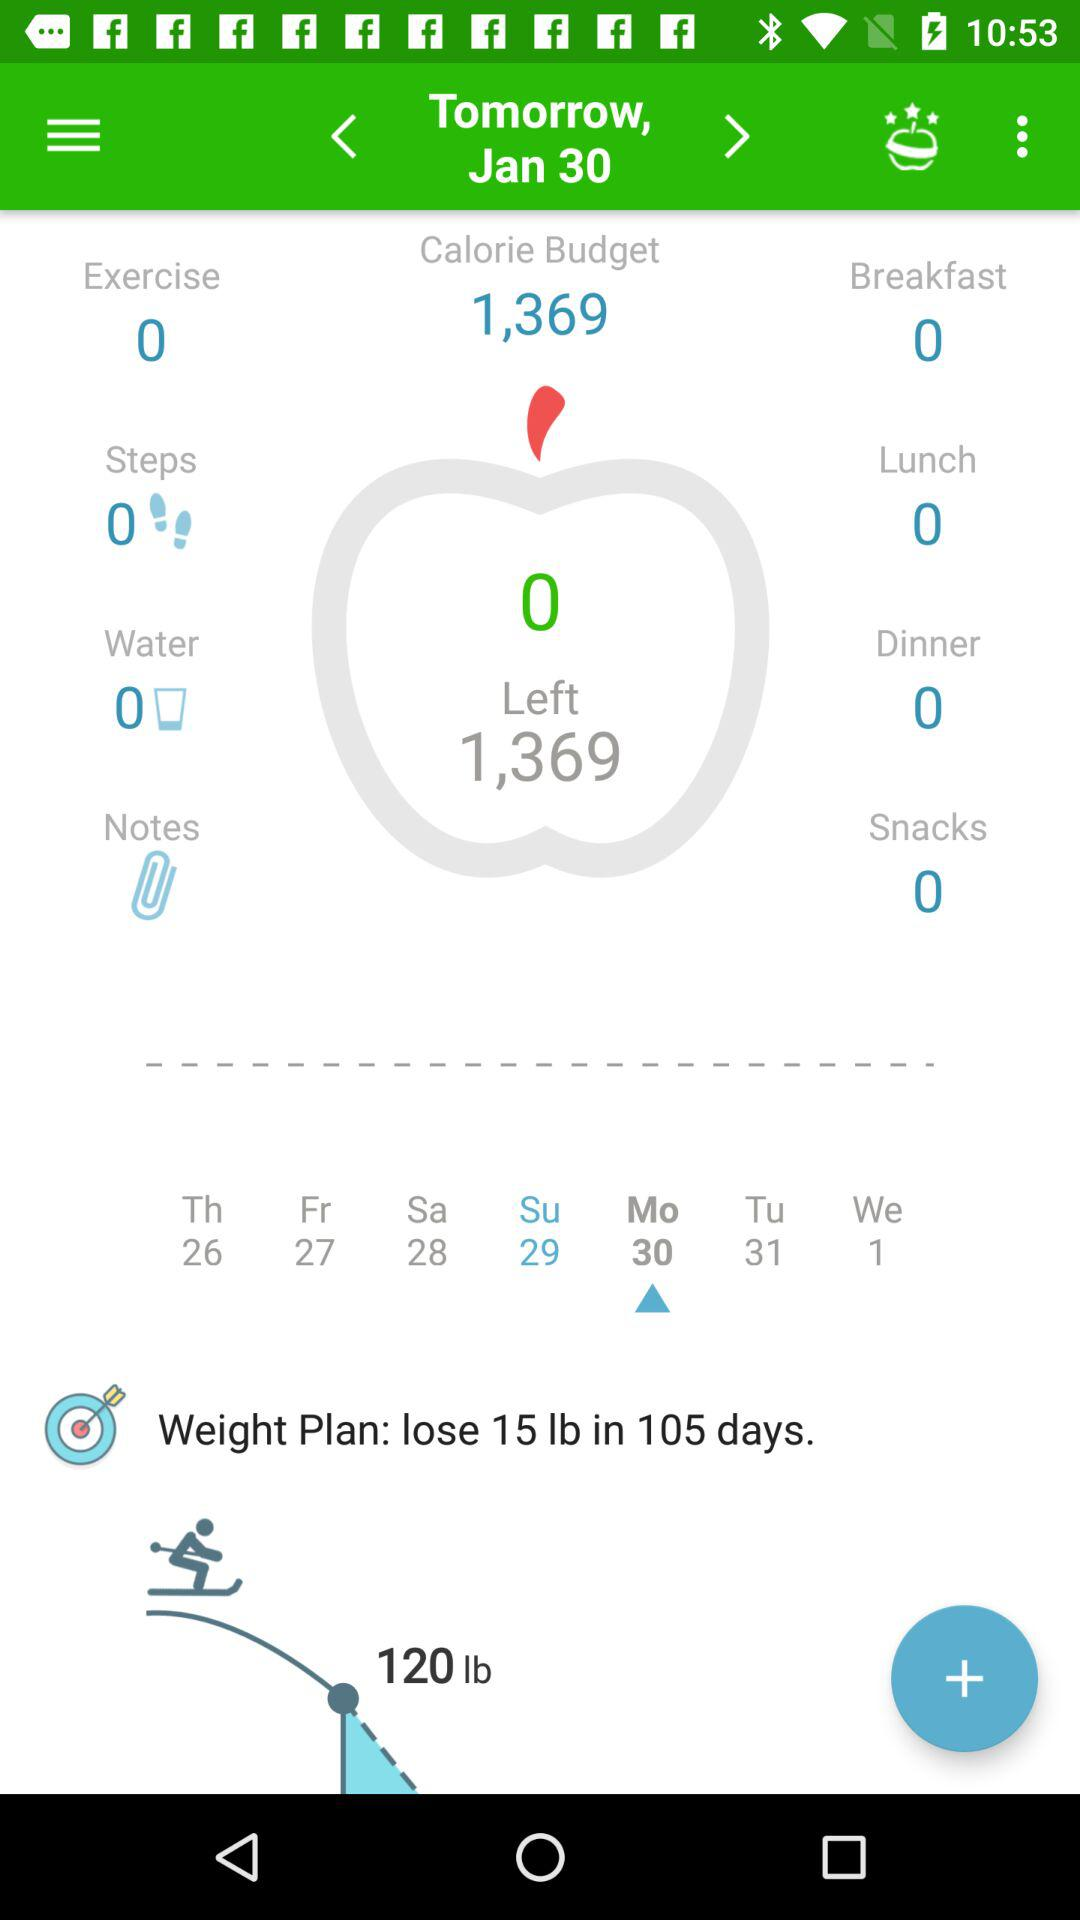How many calories are left in my budget?
Answer the question using a single word or phrase. 1,369 